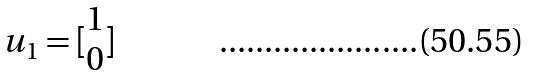<formula> <loc_0><loc_0><loc_500><loc_500>u _ { 1 } = [ \begin{matrix} 1 \\ 0 \end{matrix} ]</formula> 